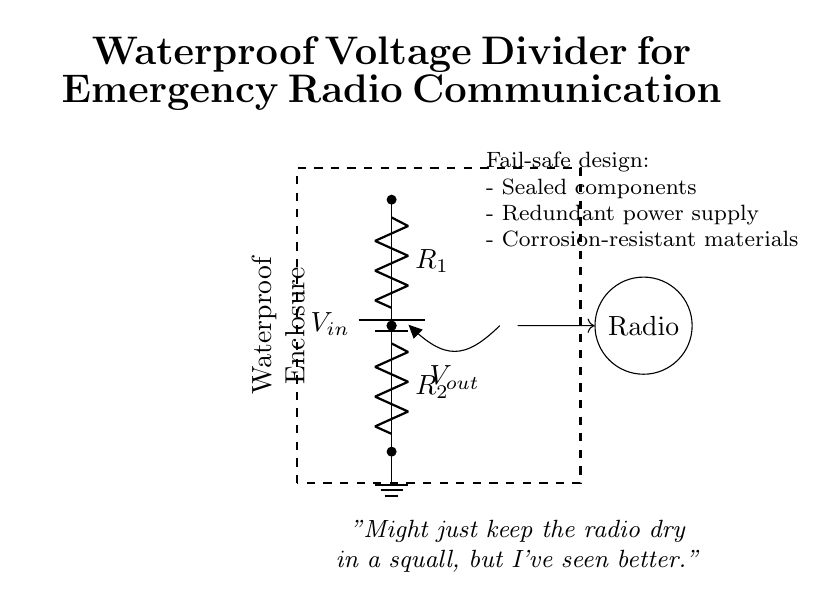What is the input voltage in this circuit? The input voltage is indicated as V_in, which is the voltage supplied by the battery at the top of the circuit.
Answer: V_in What are the resistor values in this voltage divider? The circuit diagram does not specify numerical values for R_1 and R_2, only that they are labeled as R_1 and R_2.
Answer: R_1 and R_2 How many resistors are present in the voltage divider? The diagram shows two distinct resistors, R_1 and R_2, connected in series within the circuit.
Answer: Two What does the output voltage represent in this context? The output voltage, labeled as V_out, is the voltage across resistor R_2 and is taken for the use of the emergency radio system.
Answer: V_out What additional features contribute to the fail-safe design? The annotations note sealed components, a redundant power supply, and corrosion-resistant materials as features enhancing the circuit’s reliability in harsh conditions.
Answer: Sealed components, redundant power supply, corrosion-resistant materials How does the waterproof enclosure benefit the circuit? The waterproof enclosure protects the components from moisture and damage due to water exposure, which can adversely affect the functionality of the radio communication system.
Answer: Protects from moisture 